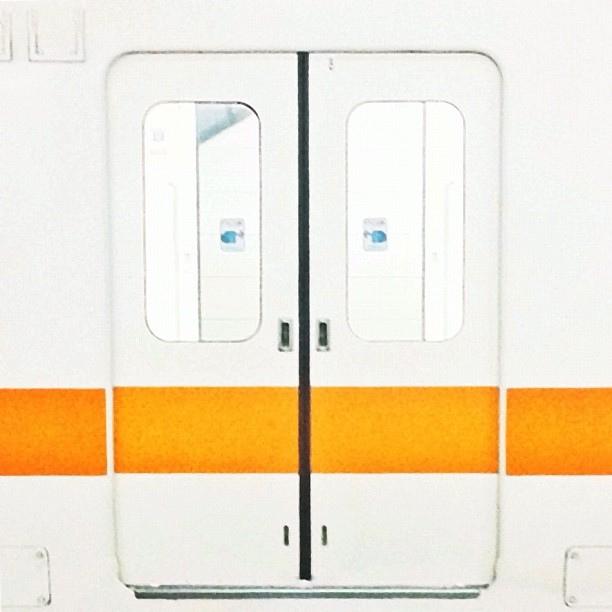Do the blue dots appear in the center of the windows or the bottoms of the windows?
Answer briefly. Center. Is the gold line vertical or horizontal?
Short answer required. Horizontal. How many yellow stripes are in this picture?
Short answer required. 1. 